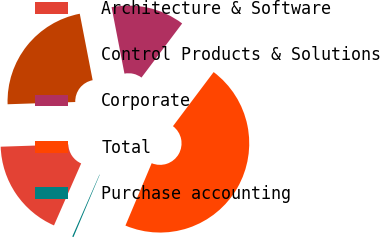Convert chart to OTSL. <chart><loc_0><loc_0><loc_500><loc_500><pie_chart><fcel>Architecture & Software<fcel>Control Products & Solutions<fcel>Corporate<fcel>Total<fcel>Purchase accounting<nl><fcel>17.89%<fcel>22.48%<fcel>13.31%<fcel>46.08%<fcel>0.24%<nl></chart> 